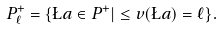<formula> <loc_0><loc_0><loc_500><loc_500>P ^ { + } _ { \ell } = \{ \L a \in P ^ { + } | \leq v ( \L a ) = \ell \} .</formula> 